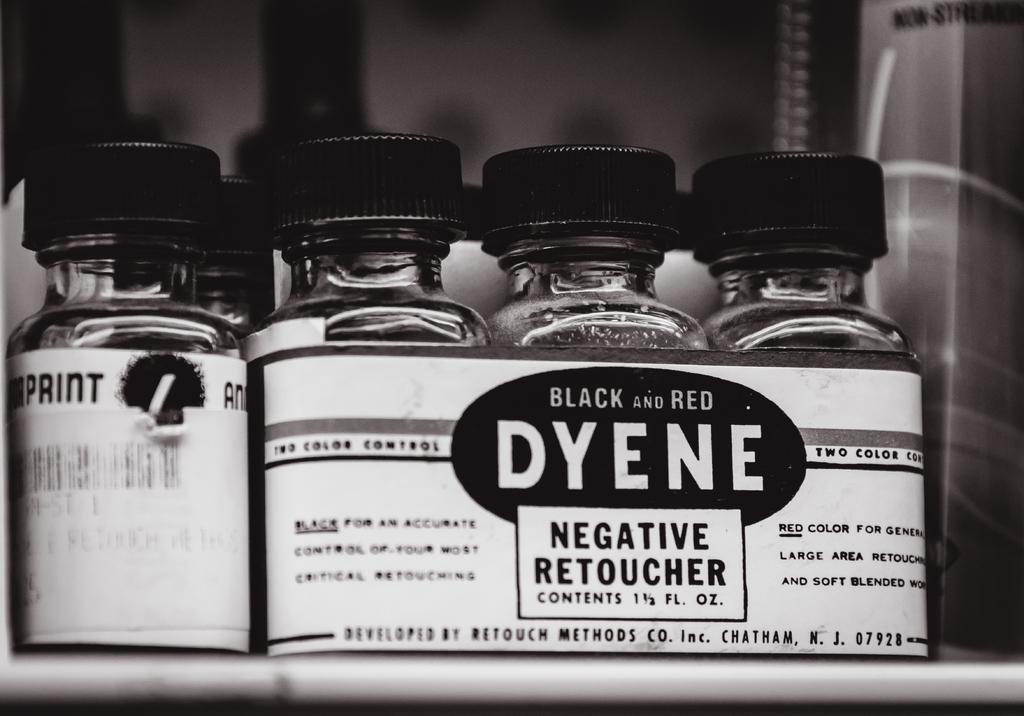What type of objects are in the image with caps? There are containers with caps in the image. What is attached to the containers? There is a paper attached to the containers. What can be read on the paper? The name "Dyene" is written on the paper. What type of trail is visible in the image? There is no trail visible in the image; it features containers with caps and a paper with the name "Dyene" written on it. 